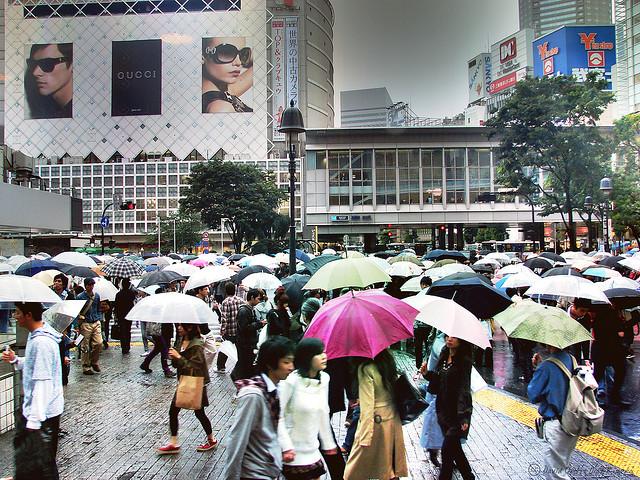How many umbrellas are pink?
Write a very short answer. 1. What does the middle advertising poster say?
Short answer required. Gucci. Do you see a clock?
Write a very short answer. No. Is it raining?
Write a very short answer. Yes. How many umbrellas are visible?
Short answer required. 100. Where is the nearest pink Umbrella?
Answer briefly. Middle. 